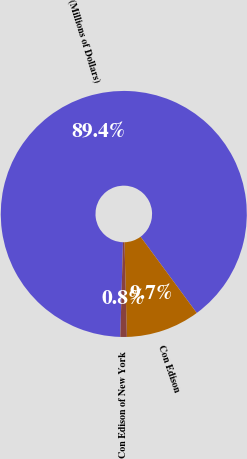Convert chart to OTSL. <chart><loc_0><loc_0><loc_500><loc_500><pie_chart><fcel>(Millions of Dollars)<fcel>Con Edison<fcel>Con Edison of New York<nl><fcel>89.45%<fcel>9.71%<fcel>0.85%<nl></chart> 